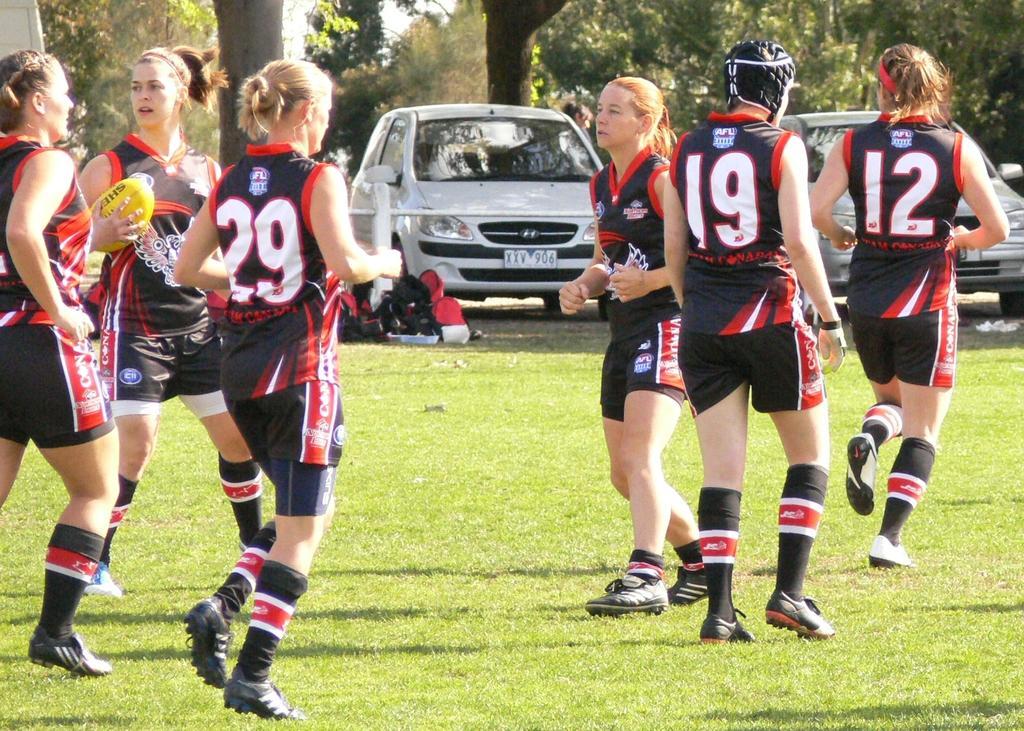How would you summarize this image in a sentence or two? In this picture we see 6 women playing a game on the grass field. In the background, we can see trees and vehicles on the road. 